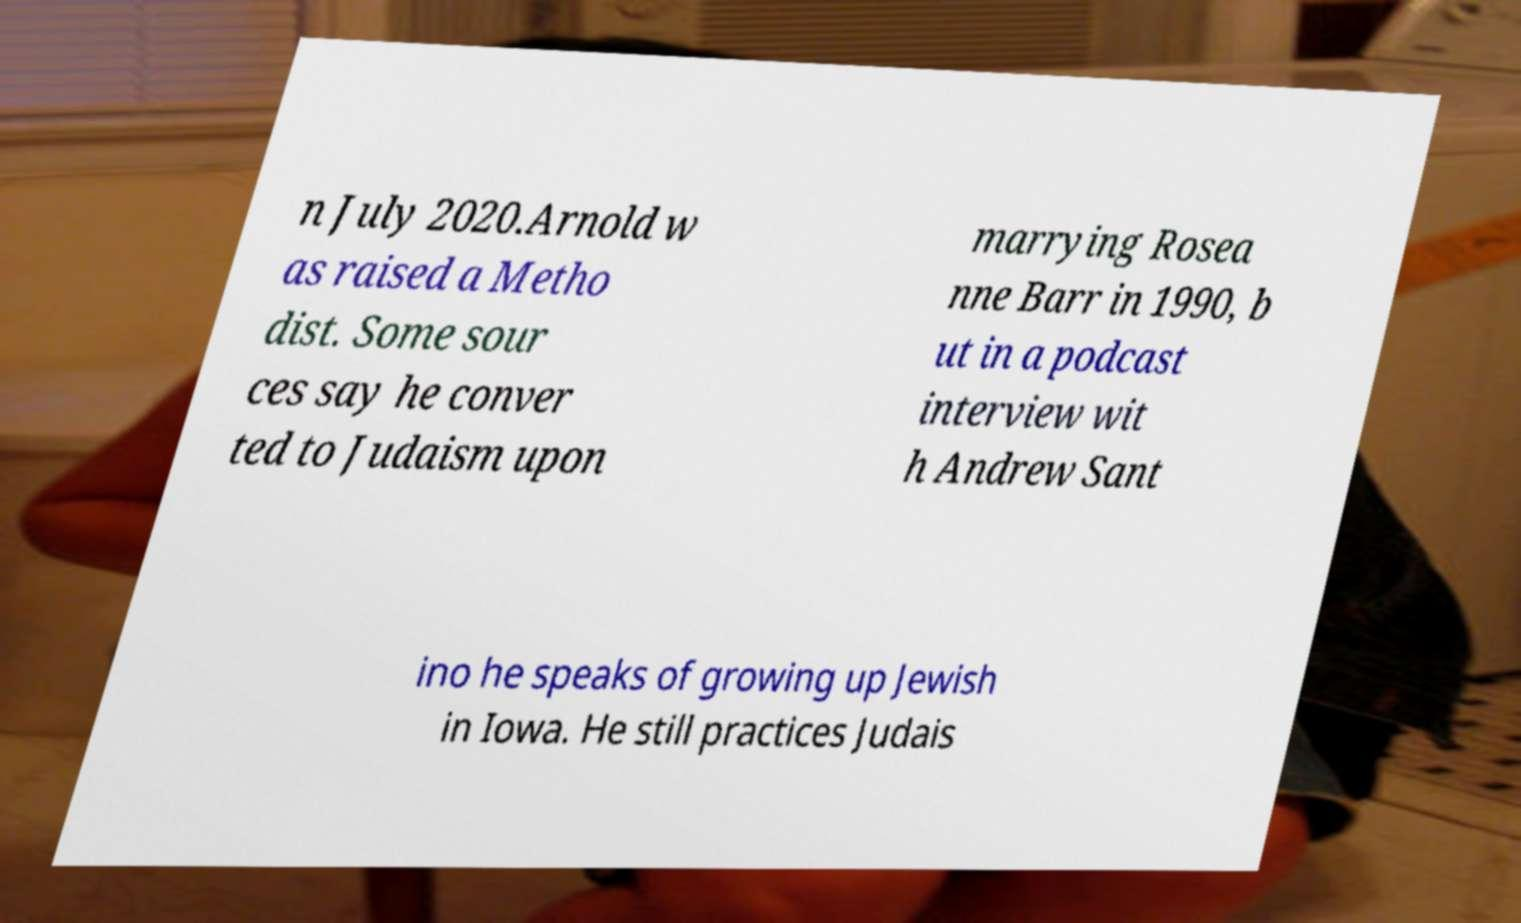Could you extract and type out the text from this image? n July 2020.Arnold w as raised a Metho dist. Some sour ces say he conver ted to Judaism upon marrying Rosea nne Barr in 1990, b ut in a podcast interview wit h Andrew Sant ino he speaks of growing up Jewish in Iowa. He still practices Judais 